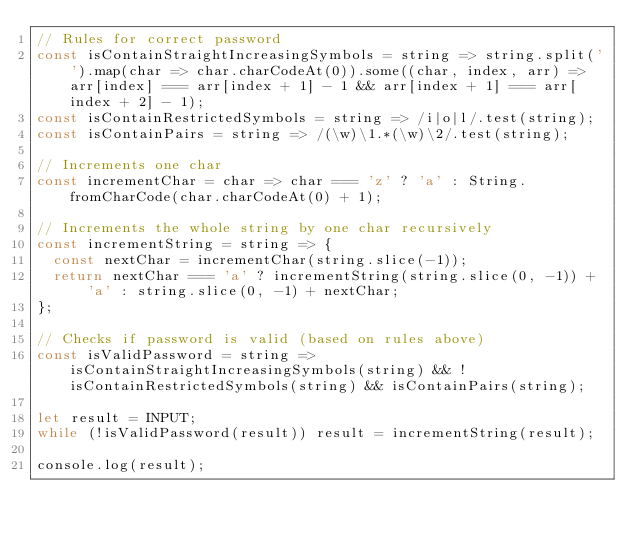Convert code to text. <code><loc_0><loc_0><loc_500><loc_500><_JavaScript_>// Rules for correct password
const isContainStraightIncreasingSymbols = string => string.split('').map(char => char.charCodeAt(0)).some((char, index, arr) => arr[index] === arr[index + 1] - 1 && arr[index + 1] === arr[index + 2] - 1);
const isContainRestrictedSymbols = string => /i|o|l/.test(string);
const isContainPairs = string => /(\w)\1.*(\w)\2/.test(string);

// Increments one char
const incrementChar = char => char === 'z' ? 'a' : String.fromCharCode(char.charCodeAt(0) + 1);

// Increments the whole string by one char recursively
const incrementString = string => {
  const nextChar = incrementChar(string.slice(-1));
  return nextChar === 'a' ? incrementString(string.slice(0, -1)) + 'a' : string.slice(0, -1) + nextChar;
};

// Checks if password is valid (based on rules above)
const isValidPassword = string => isContainStraightIncreasingSymbols(string) && !isContainRestrictedSymbols(string) && isContainPairs(string);

let result = INPUT;
while (!isValidPassword(result)) result = incrementString(result);

console.log(result);
</code> 